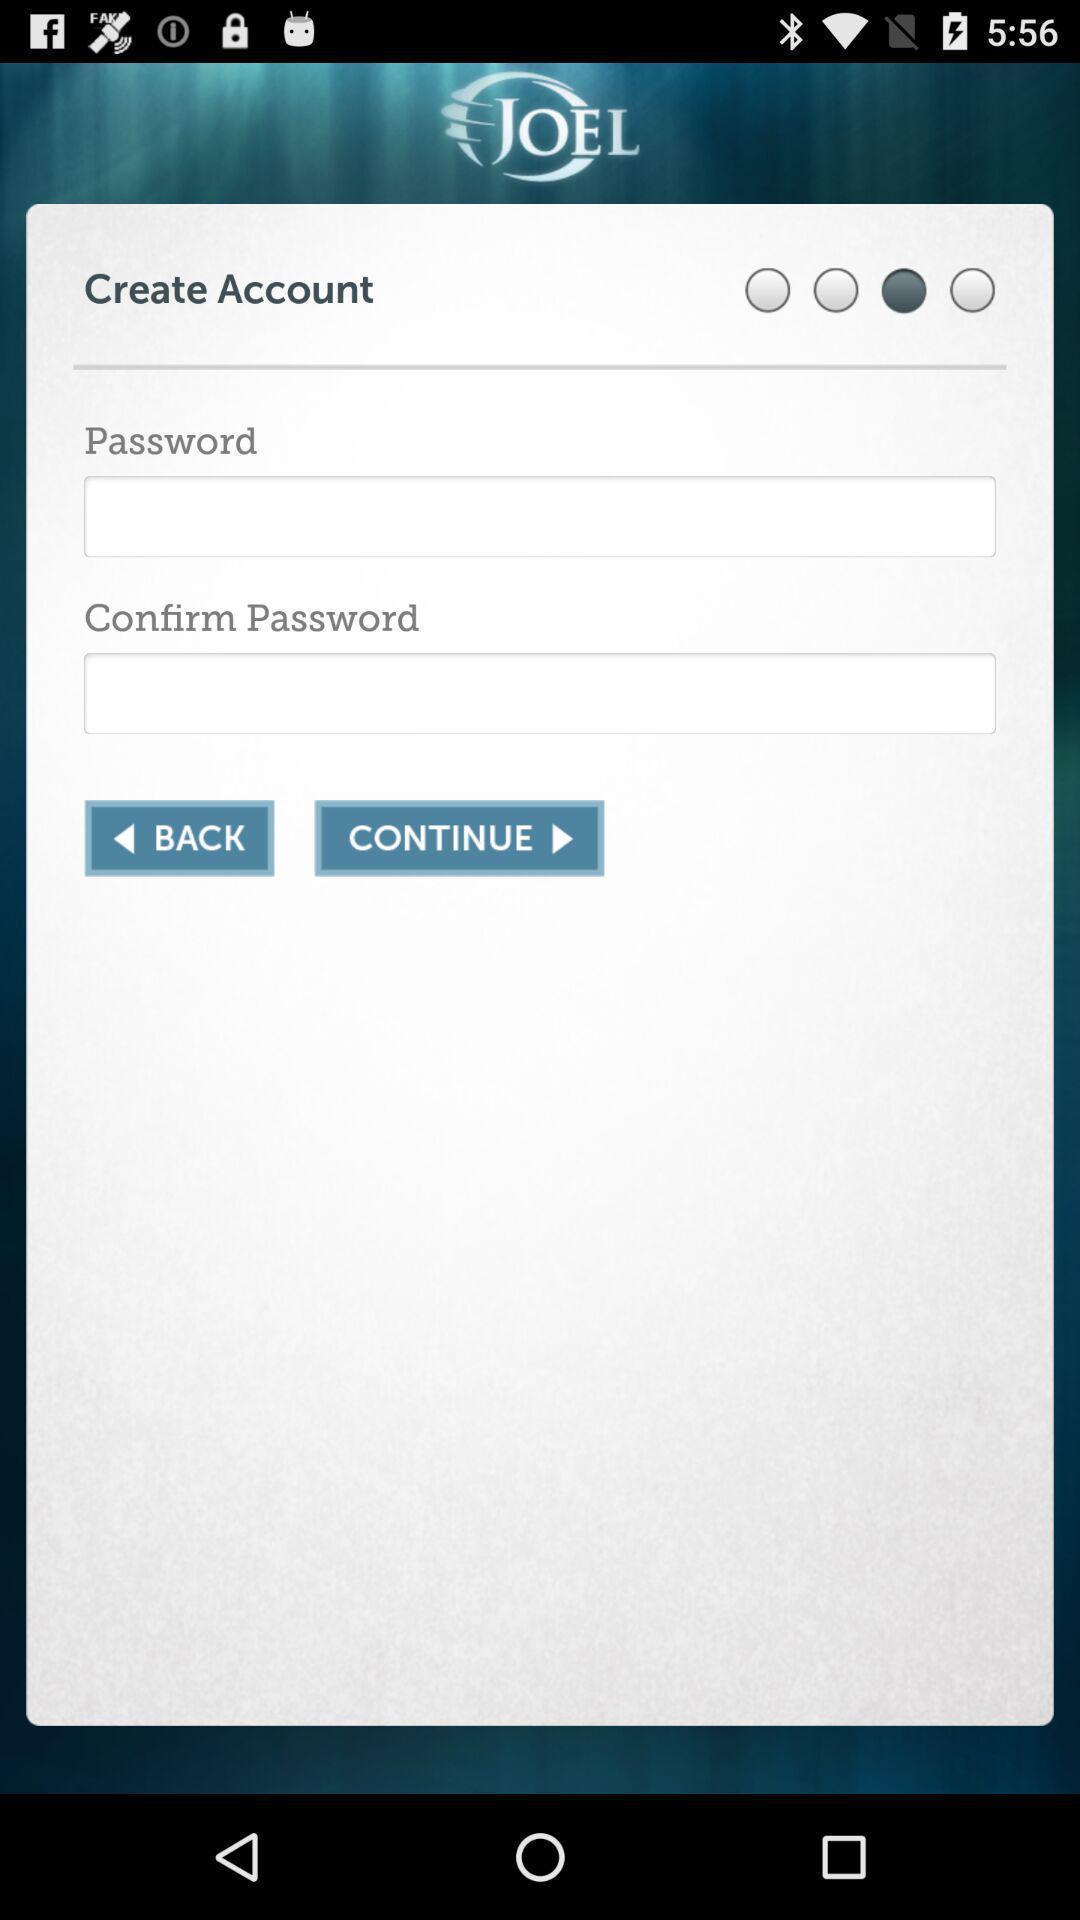Tell me about the visual elements in this screen capture. Page displays to create an account in app. 